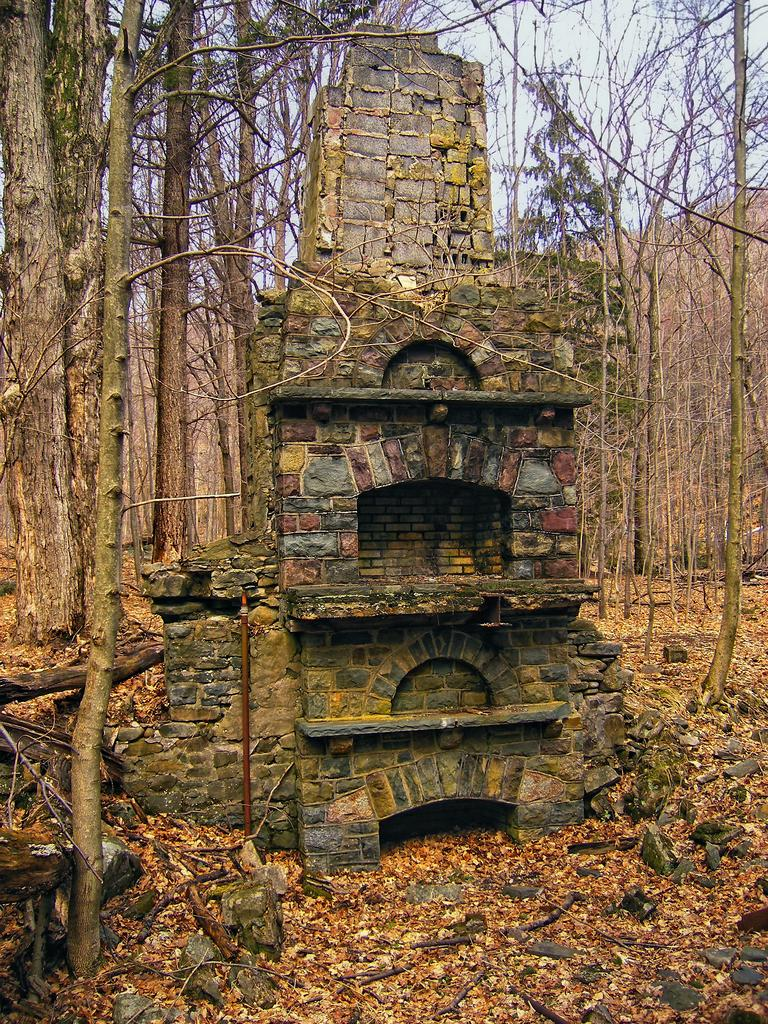What type of material is used for the walls of the building in the image? The building has brick walls. What can be seen in the background of the image? There are trees in the background. What is present on the ground in the image? There are rocks on the ground. What type of soup is being served in the jar on the ground? There is no jar or soup present in the image; it only features a building with brick walls, trees in the background, and rocks on the ground. 